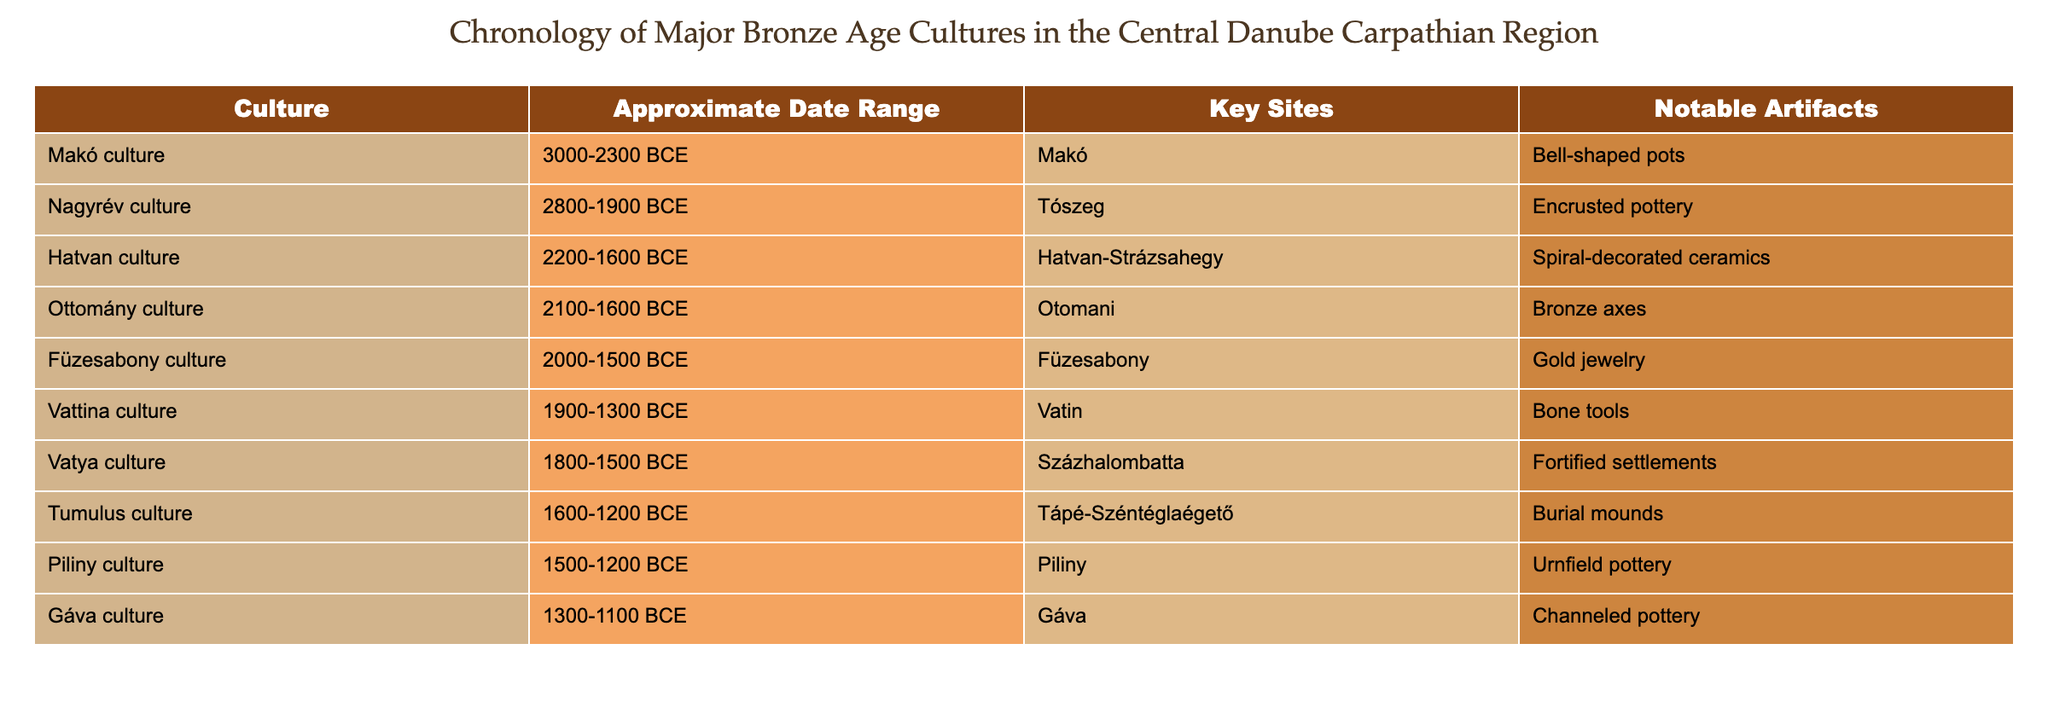What is the time range of the Makó culture? The table indicates that the Makó culture's approximate date range is from 3000 to 2300 BCE.
Answer: 3000-2300 BCE Which culture is associated with the key site of Vatin? Referring to the table, the Vattina culture is associated with the key site of Vatin.
Answer: Vattina culture Are burial mounds a notable artifact of the Hatvan culture? The table shows that burial mounds are listed under the Tumulus culture and not the Hatvan culture, making this statement false.
Answer: No What notable artifacts are linked to the Füzesabony culture? According to the table, the notable artifact linked to the Füzesabony culture is gold jewelry.
Answer: Gold jewelry What is the range of years for the cultures that fall within 2000 to 1600 BCE? The cultures in this range are the Füzesabony culture (2000-1500 BCE) and the Ottomány culture (2100-1600 BCE). Combining the time frames, they collectively show the continuation of the Bronze Age from 2100 to 1500 BCE.
Answer: 2100-1500 BCE Is the average date range of the Vatya culture greater than that of the Gáva culture? The Vatya culture has a date range of 1800 to 1500 BCE, while the Gáva culture ranges from 1300 to 1100 BCE. The date range for Vatya is larger (300 years) compared to Gáva (200 years).
Answer: Yes Which culture had the latest approximate date range and what is that range? The Tumulus culture falls within the latest range of 1600 to 1200 BCE as seen in the table.
Answer: 1600-1200 BCE How many cultures span a date range that includes 1500 BCE? The cultures that span a date range including 1500 BCE are the Füzesabony culture (2000-1500 BCE), Vatya culture (1800-1500 BCE), Piliny culture (1500-1200 BCE), and Gáva culture (1300-1100 BCE). That's four cultures in total.
Answer: 4 